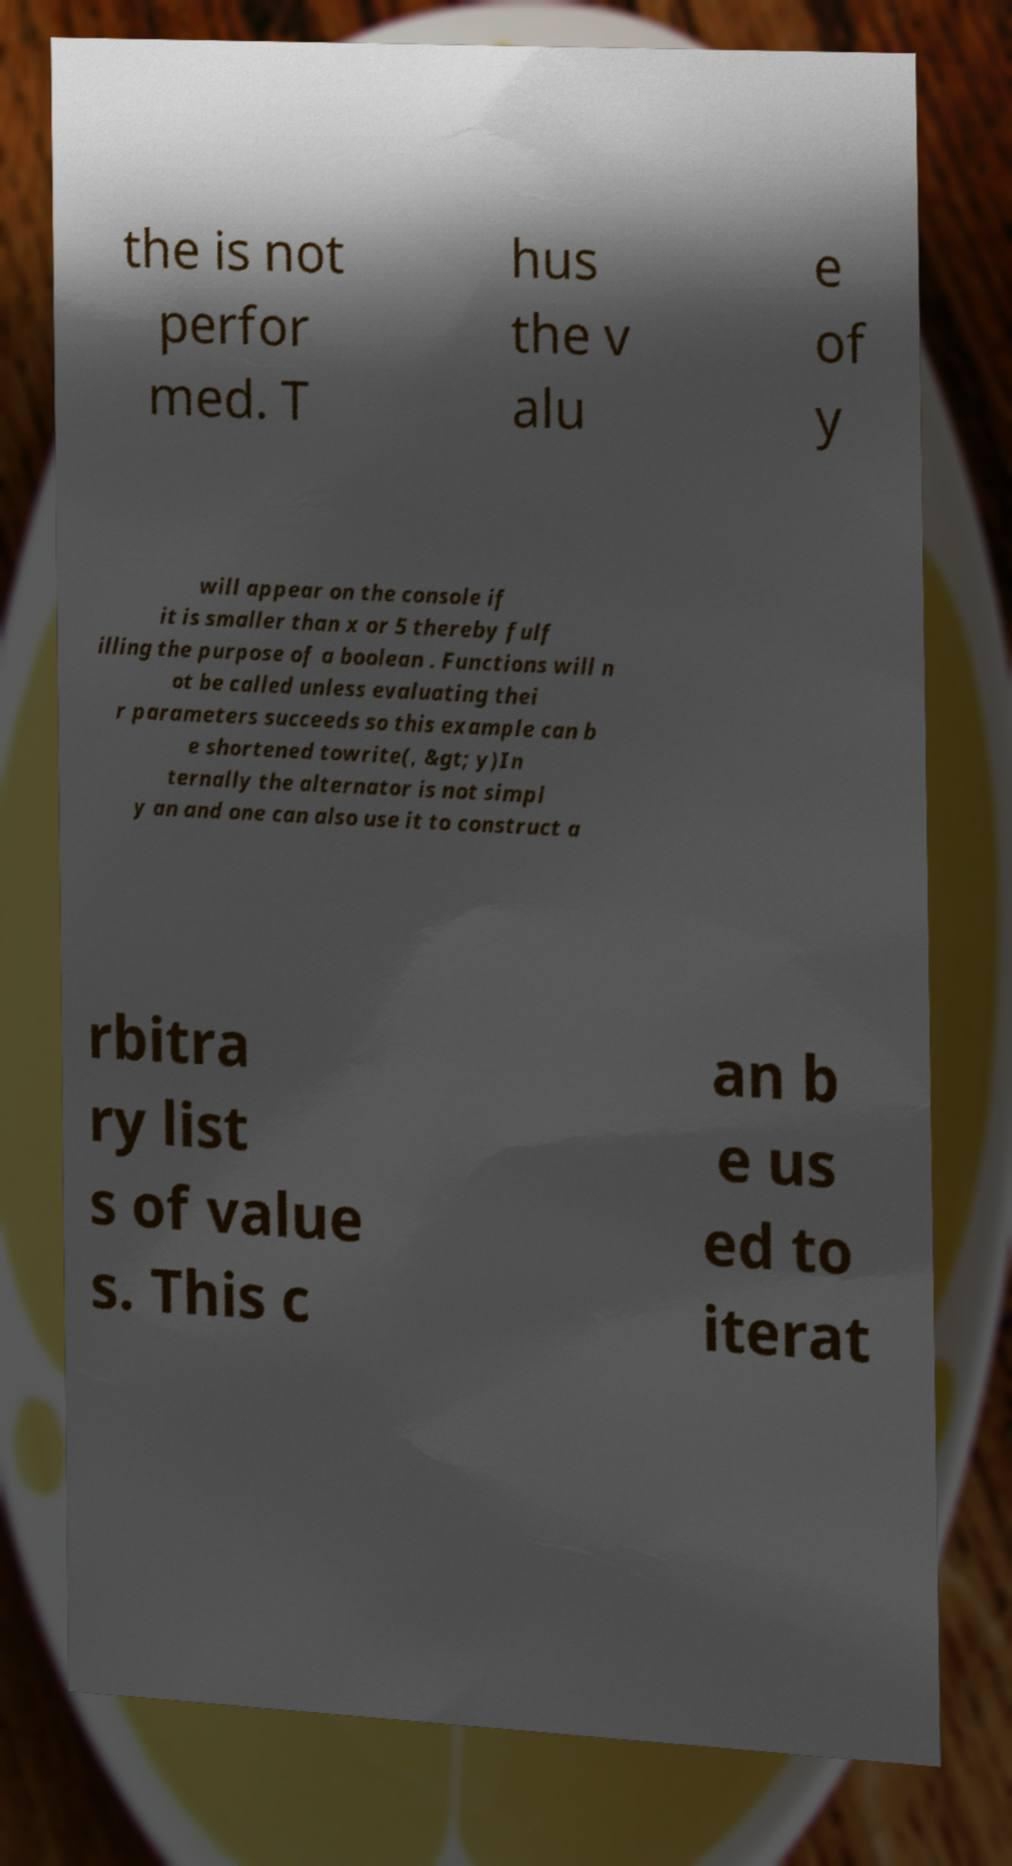I need the written content from this picture converted into text. Can you do that? the is not perfor med. T hus the v alu e of y will appear on the console if it is smaller than x or 5 thereby fulf illing the purpose of a boolean . Functions will n ot be called unless evaluating thei r parameters succeeds so this example can b e shortened towrite(, &gt; y)In ternally the alternator is not simpl y an and one can also use it to construct a rbitra ry list s of value s. This c an b e us ed to iterat 